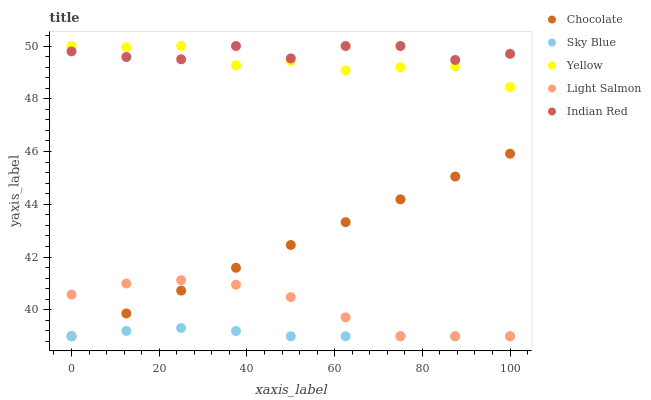Does Sky Blue have the minimum area under the curve?
Answer yes or no. Yes. Does Indian Red have the maximum area under the curve?
Answer yes or no. Yes. Does Light Salmon have the minimum area under the curve?
Answer yes or no. No. Does Light Salmon have the maximum area under the curve?
Answer yes or no. No. Is Chocolate the smoothest?
Answer yes or no. Yes. Is Indian Red the roughest?
Answer yes or no. Yes. Is Light Salmon the smoothest?
Answer yes or no. No. Is Light Salmon the roughest?
Answer yes or no. No. Does Sky Blue have the lowest value?
Answer yes or no. Yes. Does Indian Red have the lowest value?
Answer yes or no. No. Does Yellow have the highest value?
Answer yes or no. Yes. Does Light Salmon have the highest value?
Answer yes or no. No. Is Chocolate less than Indian Red?
Answer yes or no. Yes. Is Yellow greater than Light Salmon?
Answer yes or no. Yes. Does Yellow intersect Indian Red?
Answer yes or no. Yes. Is Yellow less than Indian Red?
Answer yes or no. No. Is Yellow greater than Indian Red?
Answer yes or no. No. Does Chocolate intersect Indian Red?
Answer yes or no. No. 